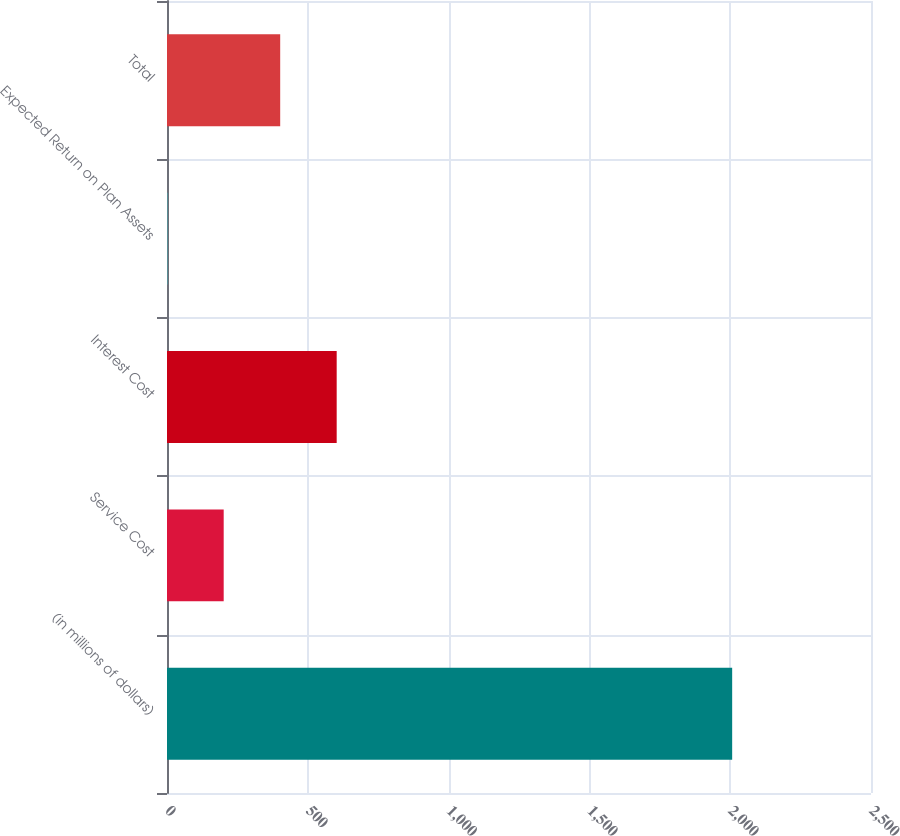Convert chart. <chart><loc_0><loc_0><loc_500><loc_500><bar_chart><fcel>(in millions of dollars)<fcel>Service Cost<fcel>Interest Cost<fcel>Expected Return on Plan Assets<fcel>Total<nl><fcel>2007<fcel>201.33<fcel>602.59<fcel>0.7<fcel>401.96<nl></chart> 